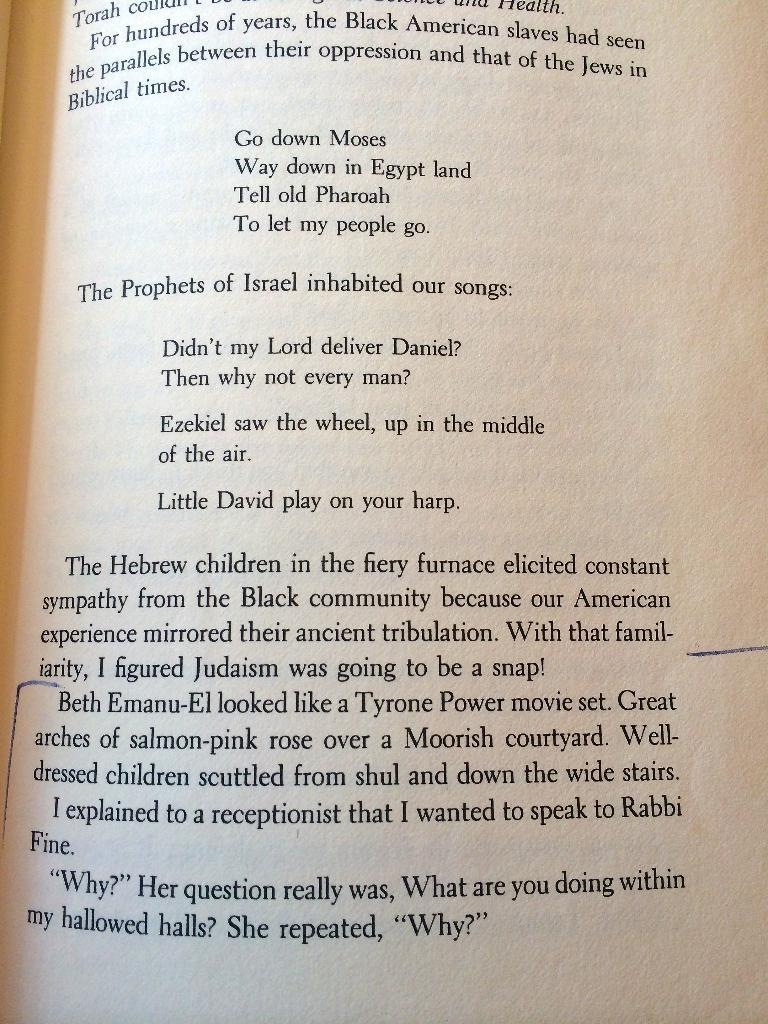<image>
Describe the image concisely. 'the prophets of israel inhabited our songs' written on a page 